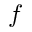<formula> <loc_0><loc_0><loc_500><loc_500>f</formula> 